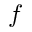<formula> <loc_0><loc_0><loc_500><loc_500>f</formula> 